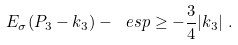Convert formula to latex. <formula><loc_0><loc_0><loc_500><loc_500>E _ { \sigma } ( P _ { 3 } - k _ { 3 } ) - \ e s p & \geq - \frac { 3 } { 4 } | k _ { 3 } | \ .</formula> 